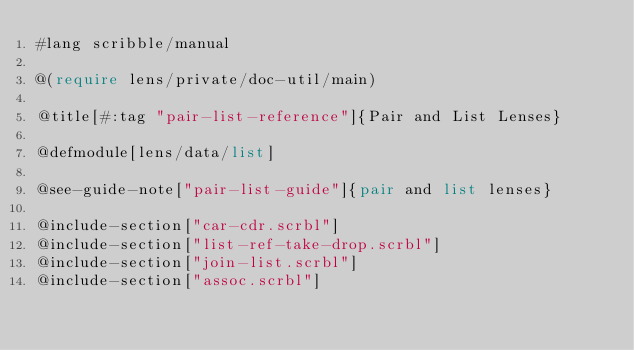Convert code to text. <code><loc_0><loc_0><loc_500><loc_500><_Racket_>#lang scribble/manual

@(require lens/private/doc-util/main)

@title[#:tag "pair-list-reference"]{Pair and List Lenses}

@defmodule[lens/data/list]

@see-guide-note["pair-list-guide"]{pair and list lenses}

@include-section["car-cdr.scrbl"]
@include-section["list-ref-take-drop.scrbl"]
@include-section["join-list.scrbl"]
@include-section["assoc.scrbl"]
</code> 